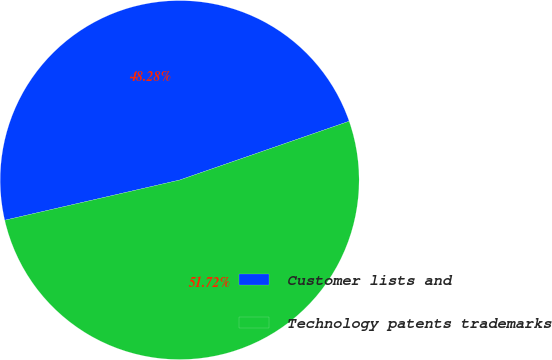Convert chart to OTSL. <chart><loc_0><loc_0><loc_500><loc_500><pie_chart><fcel>Customer lists and<fcel>Technology patents trademarks<nl><fcel>48.28%<fcel>51.72%<nl></chart> 